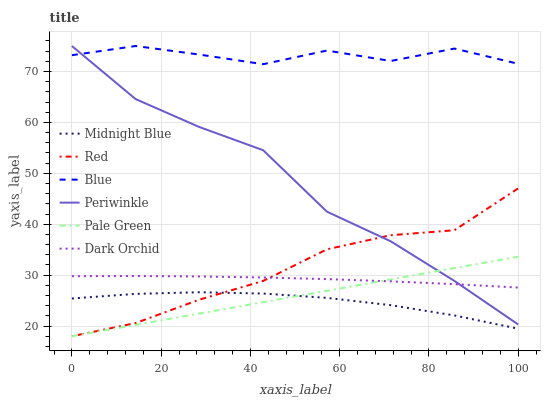Does Midnight Blue have the minimum area under the curve?
Answer yes or no. Yes. Does Blue have the maximum area under the curve?
Answer yes or no. Yes. Does Dark Orchid have the minimum area under the curve?
Answer yes or no. No. Does Dark Orchid have the maximum area under the curve?
Answer yes or no. No. Is Pale Green the smoothest?
Answer yes or no. Yes. Is Blue the roughest?
Answer yes or no. Yes. Is Midnight Blue the smoothest?
Answer yes or no. No. Is Midnight Blue the roughest?
Answer yes or no. No. Does Pale Green have the lowest value?
Answer yes or no. Yes. Does Midnight Blue have the lowest value?
Answer yes or no. No. Does Periwinkle have the highest value?
Answer yes or no. Yes. Does Dark Orchid have the highest value?
Answer yes or no. No. Is Midnight Blue less than Blue?
Answer yes or no. Yes. Is Blue greater than Red?
Answer yes or no. Yes. Does Pale Green intersect Dark Orchid?
Answer yes or no. Yes. Is Pale Green less than Dark Orchid?
Answer yes or no. No. Is Pale Green greater than Dark Orchid?
Answer yes or no. No. Does Midnight Blue intersect Blue?
Answer yes or no. No. 